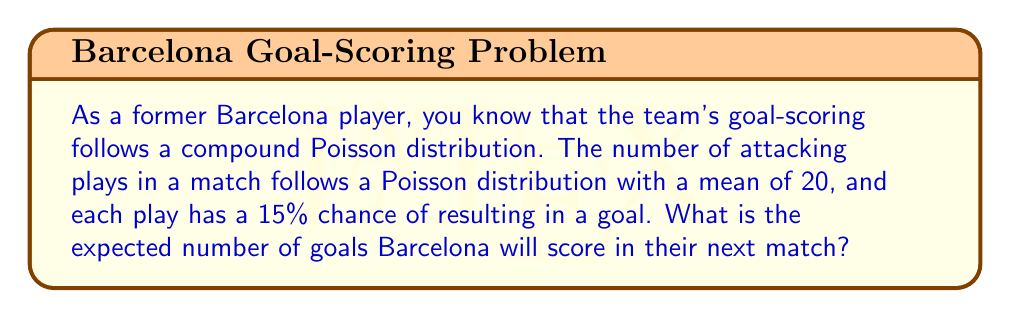Provide a solution to this math problem. Let's approach this step-by-step using the compound Poisson distribution:

1) Let $N$ be the number of attacking plays, which follows a Poisson distribution with mean $\lambda = 20$.

2) Let $X_i$ be the number of goals scored in the $i$-th play, which follows a Bernoulli distribution with $p = 0.15$ (15% chance of scoring).

3) The total number of goals $Y$ is given by:

   $Y = X_1 + X_2 + ... + X_N$

4) For a compound Poisson distribution, the expected value is given by:

   $E[Y] = E[N] \cdot E[X]$

5) We know that $E[N] = \lambda = 20$ (the mean of the Poisson distribution)

6) $E[X]$ is the expected value of the Bernoulli distribution, which is simply $p = 0.15$

7) Therefore, the expected number of goals is:

   $E[Y] = 20 \cdot 0.15 = 3$

Thus, Barcelona is expected to score 3 goals in their next match.
Answer: 3 goals 